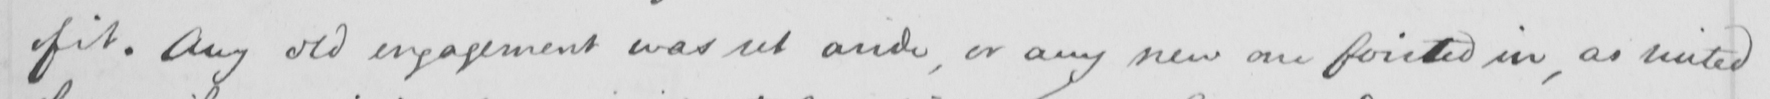Transcribe the text shown in this historical manuscript line. of it . Any old engagement was set aside , or any new one foisted in , as suited 